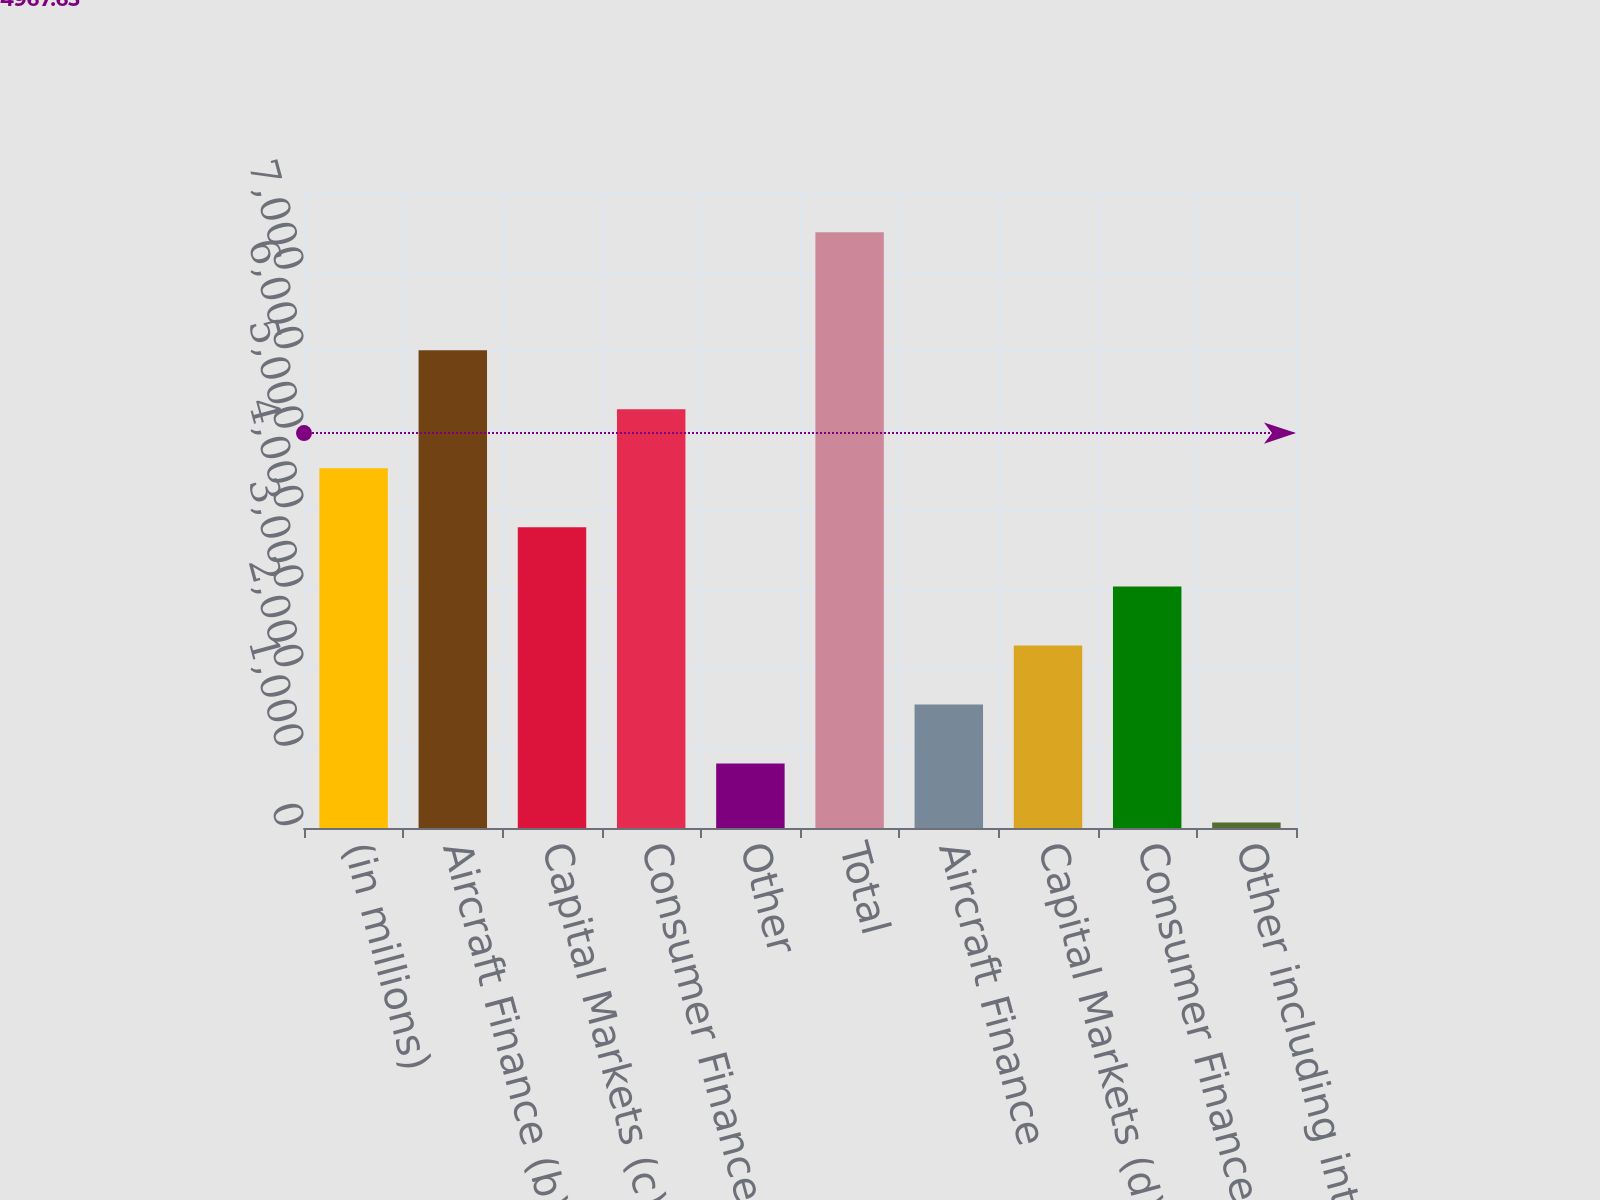Convert chart. <chart><loc_0><loc_0><loc_500><loc_500><bar_chart><fcel>(in millions)<fcel>Aircraft Finance (b)<fcel>Capital Markets (c)(d)<fcel>Consumer Finance (e)<fcel>Other<fcel>Total<fcel>Aircraft Finance<fcel>Capital Markets (d)<fcel>Consumer Finance (f)<fcel>Other including intercompany<nl><fcel>4524.2<fcel>6009.6<fcel>3781.5<fcel>5266.9<fcel>810.7<fcel>7495<fcel>1553.4<fcel>2296.1<fcel>3038.8<fcel>68<nl></chart> 